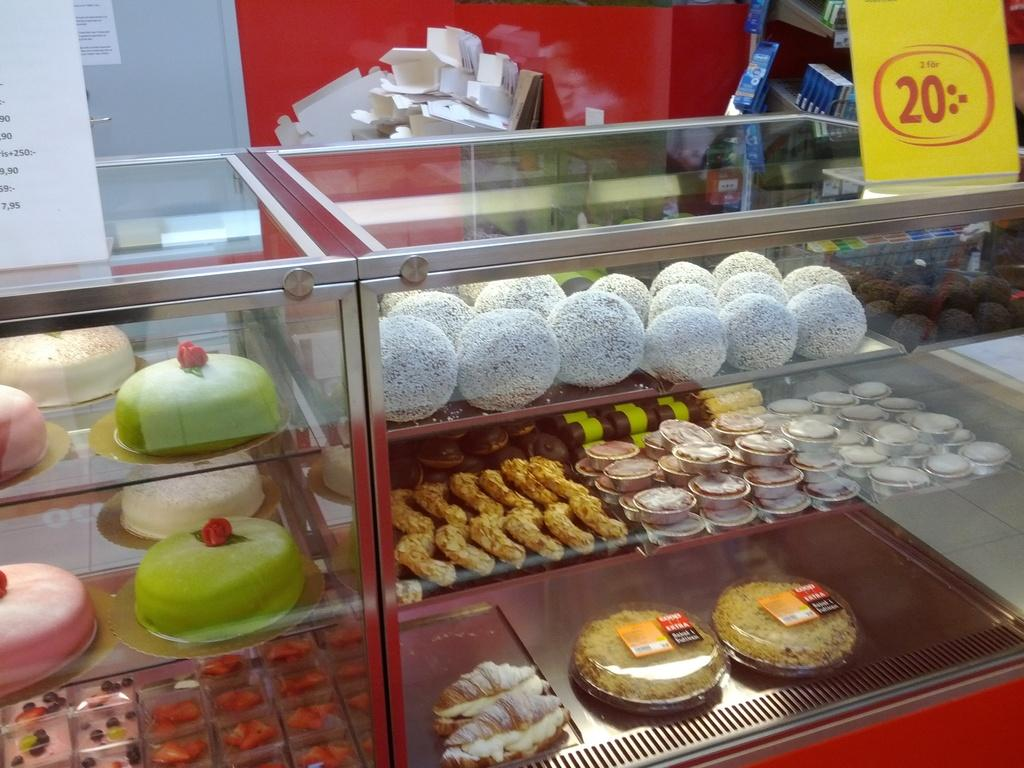What can be seen on the racks in the image? There are food items on the racks in the image. What else is present in the image besides the food items? There are boxes and boards with text in the image. How many boxes can be seen in the image? There are at least two boxes in the image, as mentioned in the facts. What is the purpose of the door in the image? The purpose of the door is to provide access to the area where the food items, boxes, and boards with text are located. What can be seen on the wall in the image? The wall is visible in the image, but no specific details about the wall are mentioned in the facts. What type of design can be seen on the downtown buildings in the image? There is no mention of downtown buildings or any specific design in the image. The image only contains food items on racks, boxes, boards with text, a door, and a visible wall. 